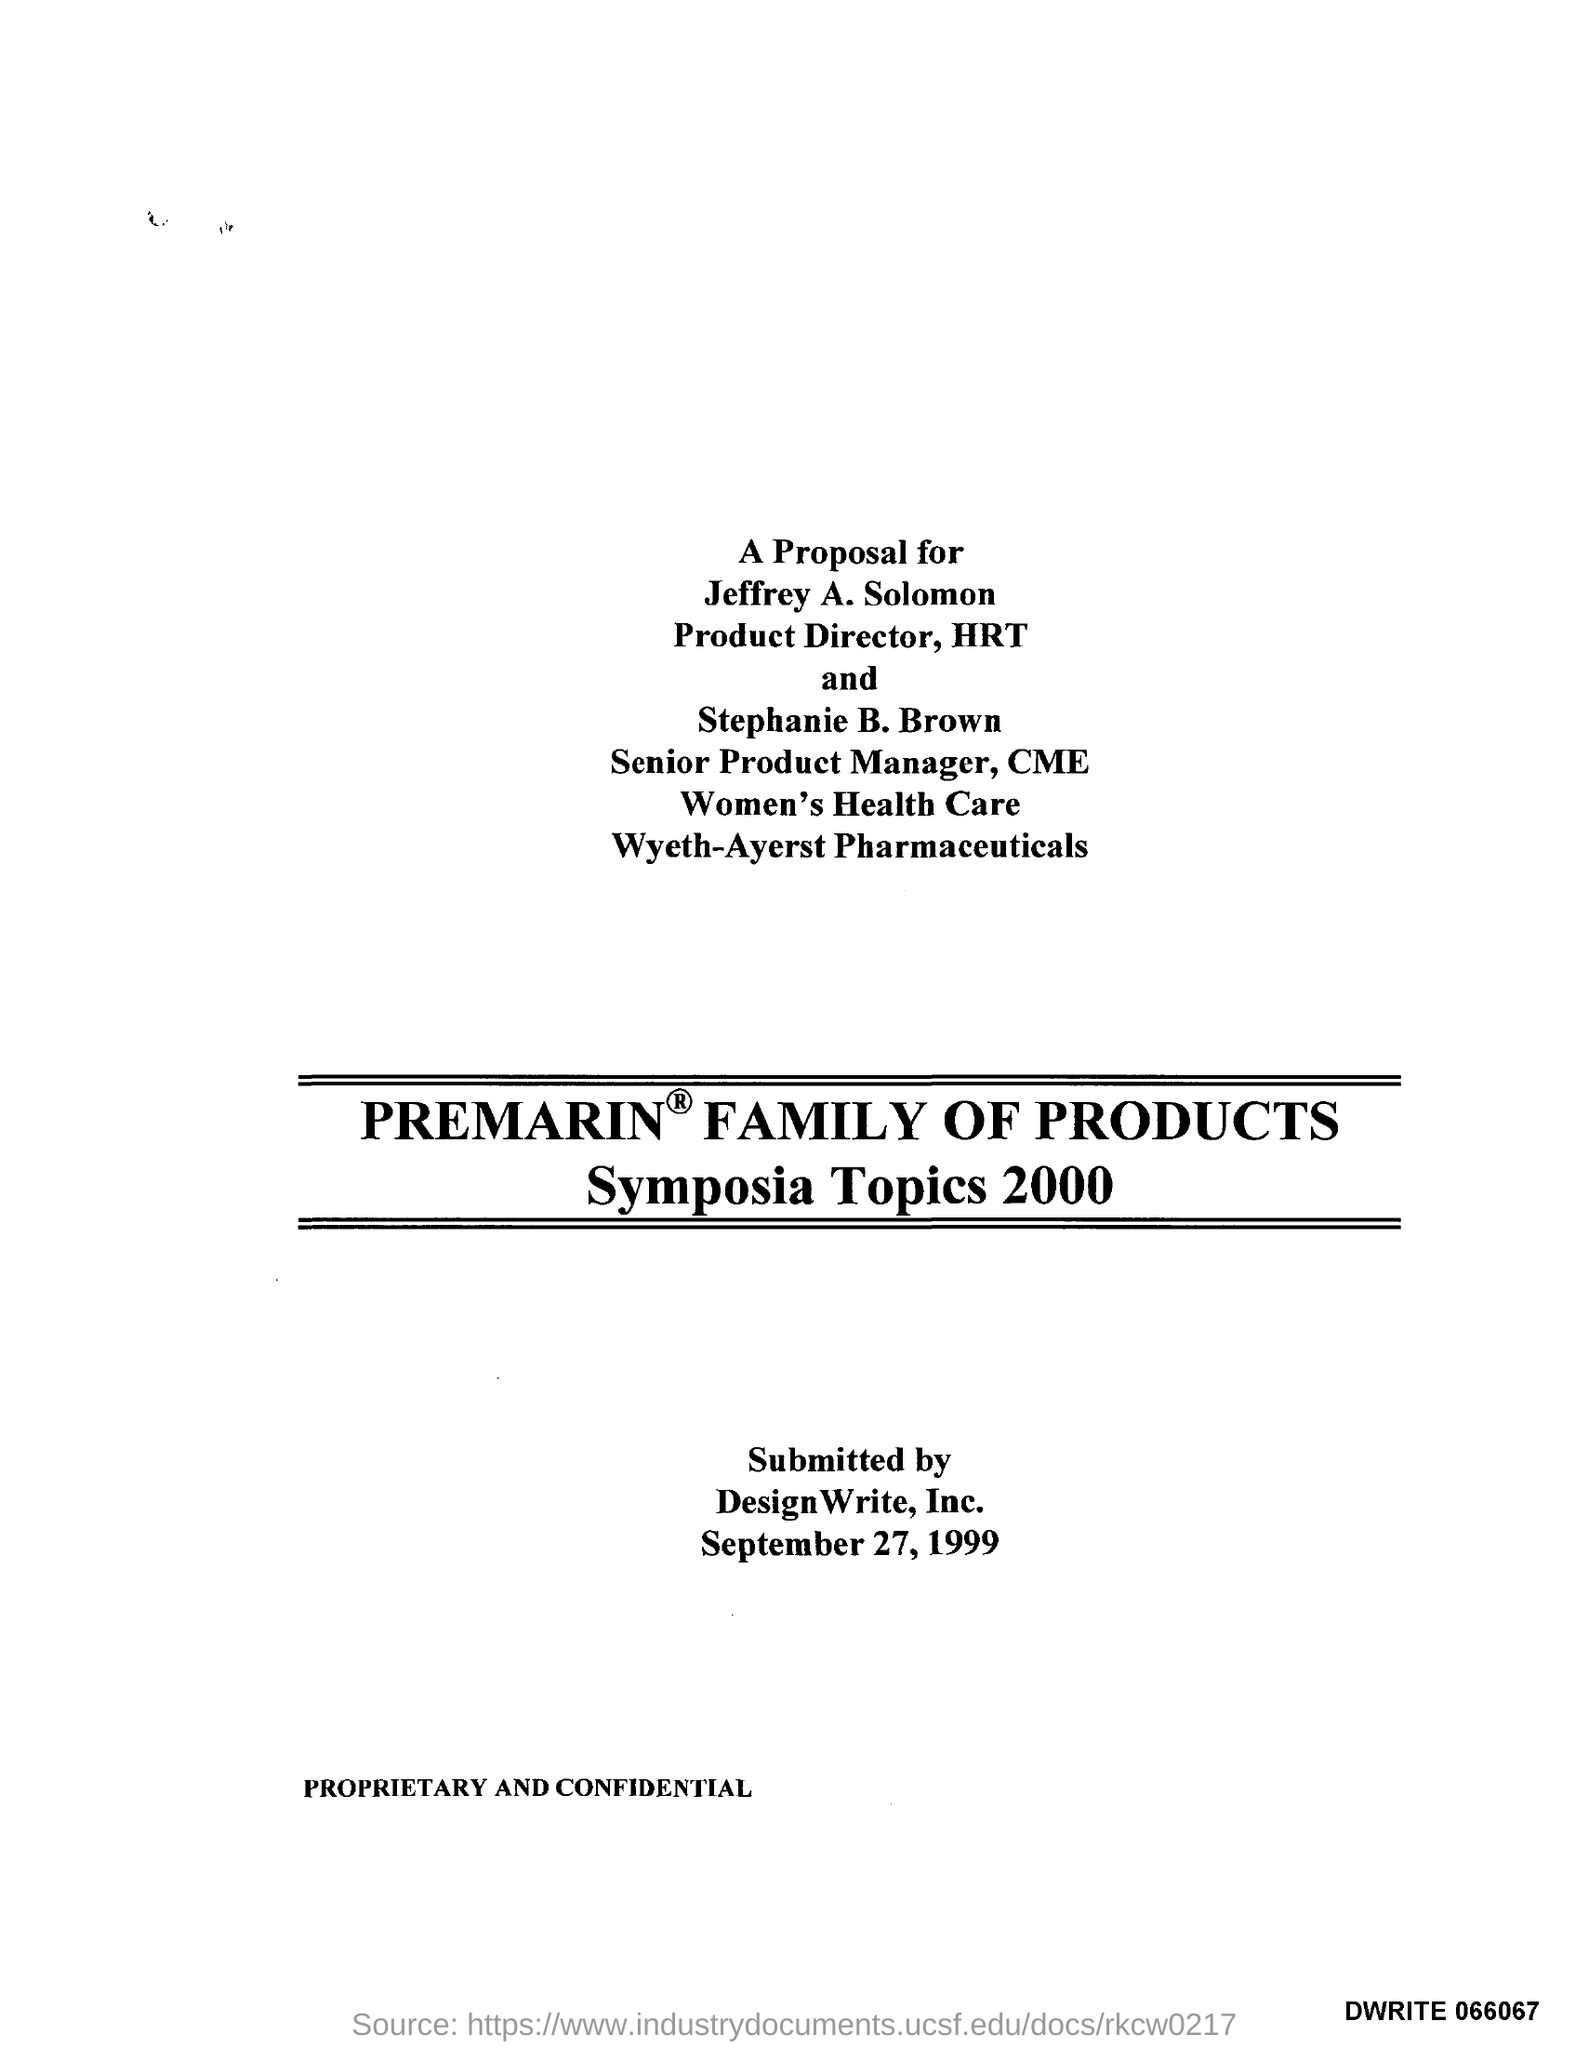Mention a couple of crucial points in this snapshot. The submission date is September 27, 1999. 